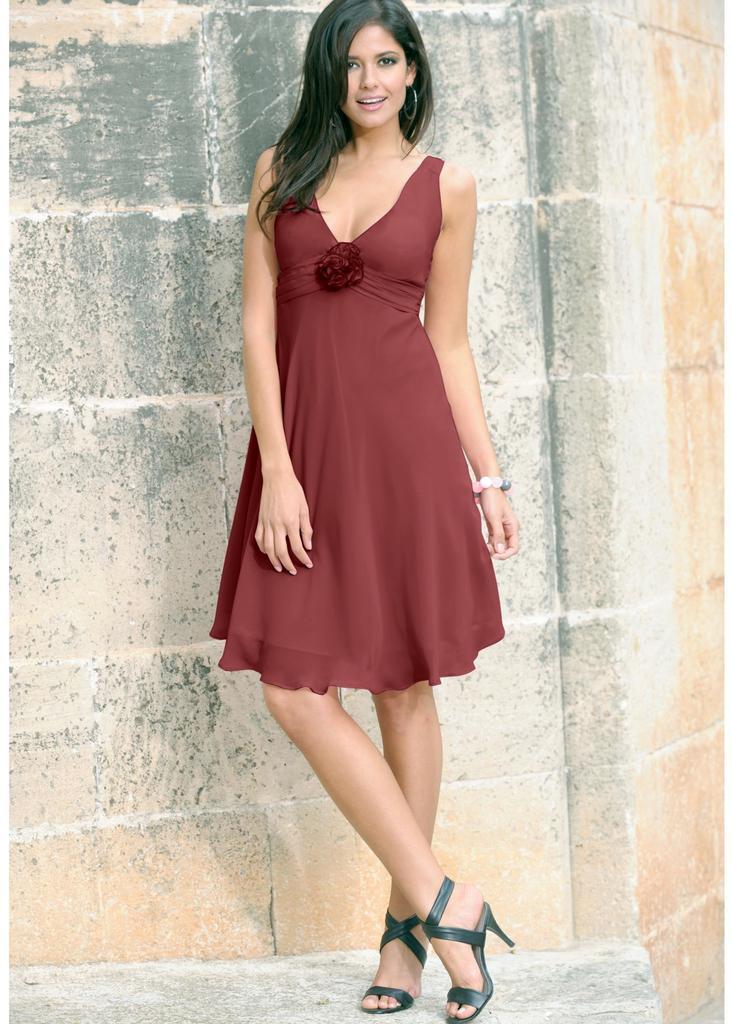Describe this image in one or two sentences. This image consists of a woman wearing brown dress. In the background, there is a wall. At the bottom, there is a ground. 